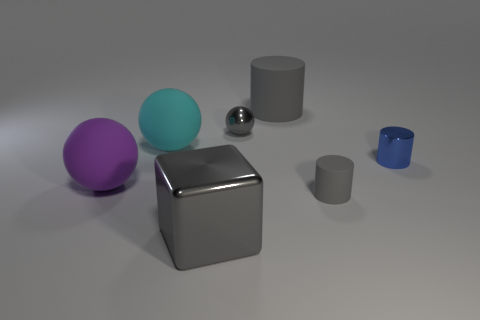What is the size of the object that is both in front of the shiny cylinder and to the left of the large gray block?
Provide a succinct answer. Large. There is a small gray thing that is behind the purple matte object that is to the left of the large gray metal block; what shape is it?
Give a very brief answer. Sphere. Is there any other thing that is the same color as the big cylinder?
Keep it short and to the point. Yes. What is the shape of the matte object to the right of the big gray cylinder?
Provide a short and direct response. Cylinder. What is the shape of the small object that is both behind the tiny gray matte thing and left of the small blue shiny cylinder?
Keep it short and to the point. Sphere. What number of green things are either large matte cylinders or cylinders?
Offer a very short reply. 0. Does the ball in front of the cyan rubber object have the same color as the big cylinder?
Your answer should be compact. No. There is a thing that is to the right of the small matte cylinder that is on the right side of the gray metallic sphere; how big is it?
Your response must be concise. Small. What material is the gray object that is the same size as the gray sphere?
Your response must be concise. Rubber. What number of other objects are there of the same size as the cyan thing?
Your answer should be compact. 3. 